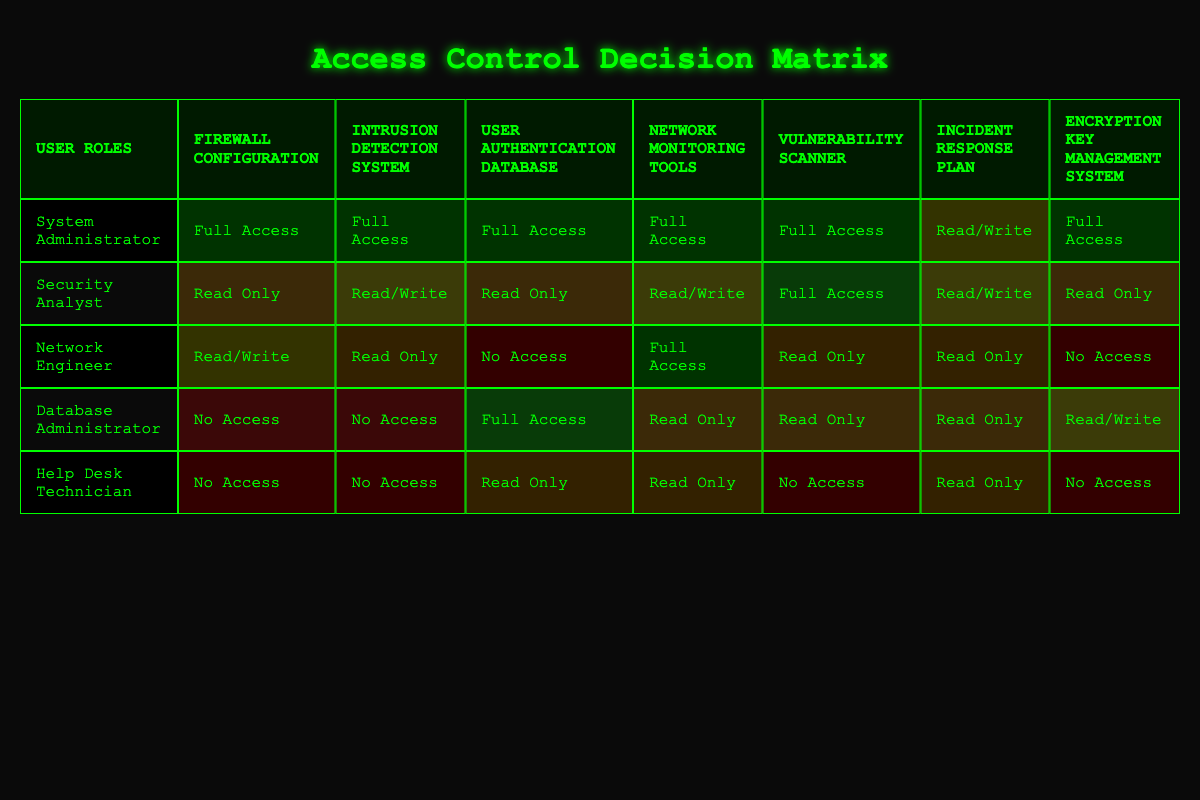What access level does the Security Analyst have for the Intrusion Detection System? The table indicates that the Security Analyst has "Read/Write" access for the Intrusion Detection System. We simply refer to the row for the Security Analyst and the corresponding column for the Intrusion Detection System to find this information.
Answer: Read/Write Which user role has "No Access" to the Firewall Configuration? By examining the table, we can see that both the Database Administrator and the Help Desk Technician have "No Access" to the Firewall Configuration. We refer to the respective rows for these roles and check the Firewall Configuration column.
Answer: Database Administrator, Help Desk Technician How many user roles have "Full Access" to the Encryption Key Management System? In the Encryption Key Management System column, we identify which user roles have "Full Access." These roles are System Administrator and Database Administrator. Counting them gives us two user roles with "Full Access."
Answer: 2 Is it true that the Network Engineer has "Read Only" access to the User Authentication Database? Looking at the table, we find that the Network Engineer does not have "Read Only" access but has "No Access" instead for the User Authentication Database. We check the Network Engineer's row and the User Authentication Database column to confirm this information.
Answer: No What is the role with the least access levels overall and what is the access level for the Vulnerability Scanner? To find the role with the least access levels, we examine all roles and tally their access levels. After counting, we find that the Help Desk Technician has the most "No Access" rights (4 out of 6 resources). For the Vulnerability Scanner, the Help Desk Technician has "No Access." We can confirm this by consulting the Help Desk Technician's row for the corresponding column.
Answer: Help Desk Technician, No Access What access level do both the Security Analyst and Network Engineer have for the Network Monitoring Tools? By checking the corresponding rows for both user roles in the Network Monitoring Tools column, we observe that the Security Analyst has "Read/Write" access while the Network Engineer has "Full Access." This provides a clear comparison between the two roles regarding this resource.
Answer: Security Analyst: Read/Write, Network Engineer: Full Access What is the total number of access levels across all user roles for the Incident Response Plan? We look up the access levels in the Incident Response Plan column for each user role, noting the values: Read/Write, Read/Write, Read Only, Read Only, Read Only. Summarizing these, four roles have access rights of either Read/Write or Read Only.
Answer: 4 Which user role(s) have access to both the Firewall Configuration and Incident Response Plan? By analyzing the table, we check the Firewall Configuration and Incident Response Plan columns. The System Administrator has "Full Access" for both, and the Security Analyst has "Read Only" for the Firewall Configuration and "Read/Write" for the Incident Response Plan. The Network Engineer does not have access to the Firewall Configuration, and the Database Administrator has "No Access" to the Firewall Configuration but access for the Incident Response Plan. Thus, the roles with at least some level of access are the System Administrator and the Security Analyst.
Answer: System Administrator, Security Analyst 